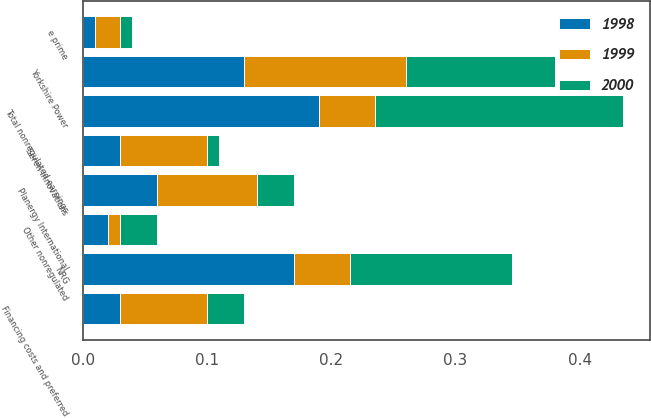Convert chart. <chart><loc_0><loc_0><loc_500><loc_500><stacked_bar_chart><ecel><fcel>NRG<fcel>Yorkshire Power<fcel>e prime<fcel>Seren Innovations<fcel>Planergy International<fcel>Financing costs and preferred<fcel>Other nonregulated<fcel>Total nonregulated earnings<nl><fcel>1999<fcel>0.045<fcel>0.13<fcel>0.02<fcel>0.07<fcel>0.08<fcel>0.07<fcel>0.01<fcel>0.045<nl><fcel>1998<fcel>0.17<fcel>0.13<fcel>0.01<fcel>0.03<fcel>0.06<fcel>0.03<fcel>0.02<fcel>0.19<nl><fcel>2000<fcel>0.13<fcel>0.12<fcel>0.01<fcel>0.01<fcel>0.03<fcel>0.03<fcel>0.03<fcel>0.2<nl></chart> 